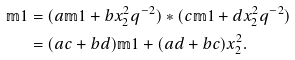Convert formula to latex. <formula><loc_0><loc_0><loc_500><loc_500>\mathbb { m } { 1 } & = ( a \mathbb { m } { 1 } + b x _ { 2 } ^ { 2 } q ^ { - 2 } ) * ( c \mathbb { m } { 1 } + d x _ { 2 } ^ { 2 } q ^ { - 2 } ) \\ & = ( a c + b d ) \mathbb { m } { 1 } + ( a d + b c ) x _ { 2 } ^ { 2 } .</formula> 